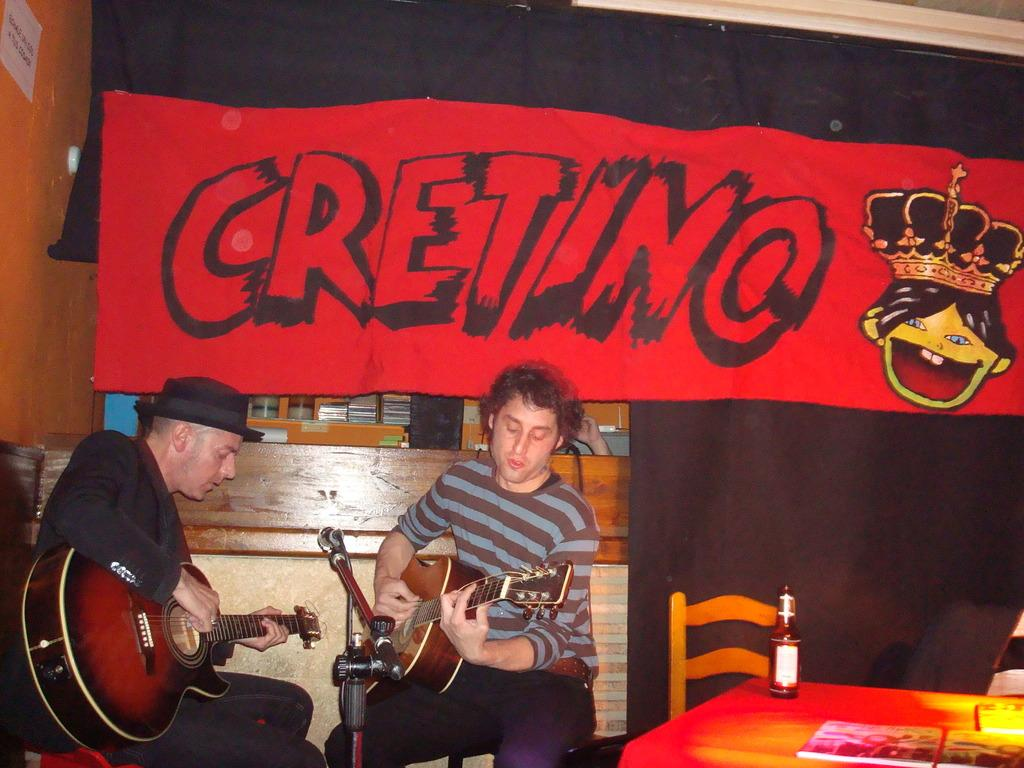How many people are in the image? There are two persons sitting in the image. What are the persons doing in the image? The persons are playing guitar. What equipment is present for amplifying sound in the image? There is a microphone with a stand in the image. What type of furniture is visible in the image? There are chairs and a table in the image. What items can be seen on the table? There is a bottle and books on the table. What can be seen in the background of the image? There is a banner and a wall in the background. Who is the owner of the organization in the image? There is no mention of an organization or an owner in the image. 